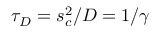Convert formula to latex. <formula><loc_0><loc_0><loc_500><loc_500>\tau _ { D } = s _ { c } ^ { 2 } / D = 1 / \gamma</formula> 